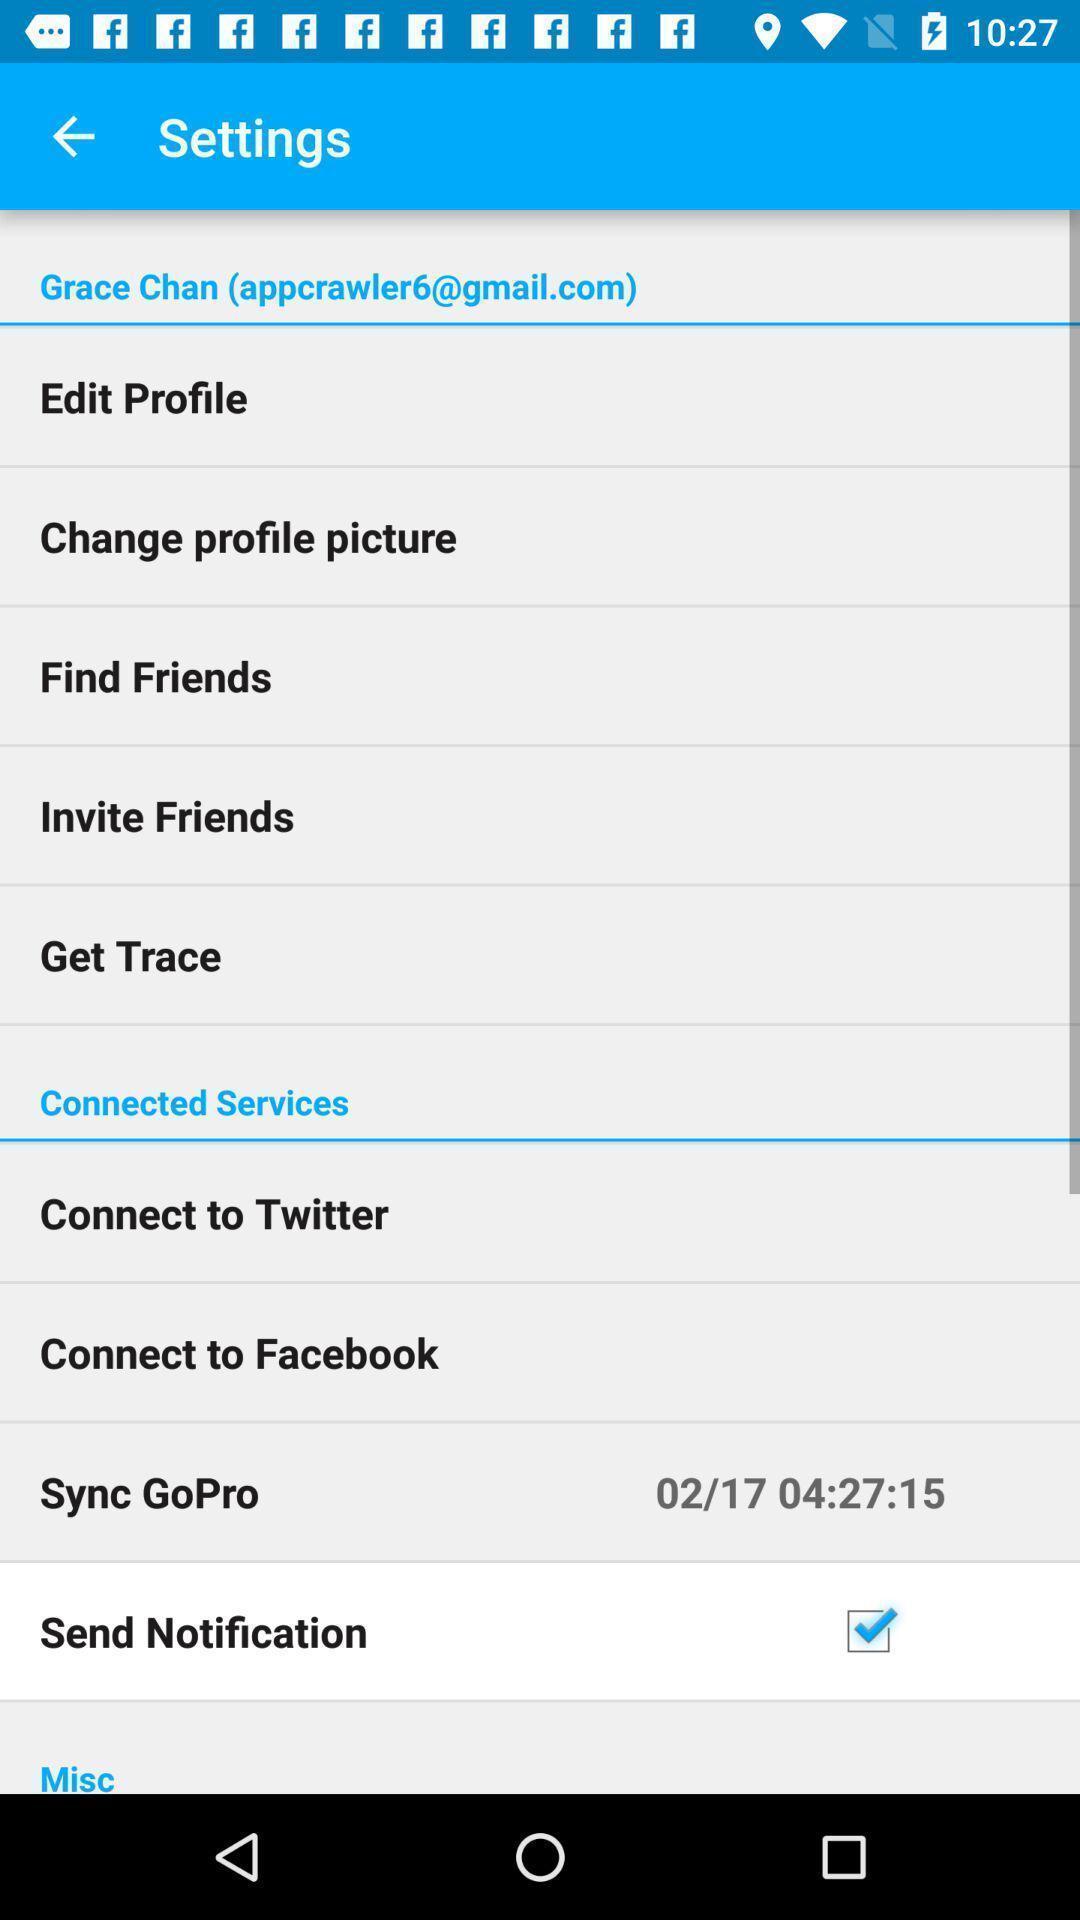Provide a description of this screenshot. Settings page. 